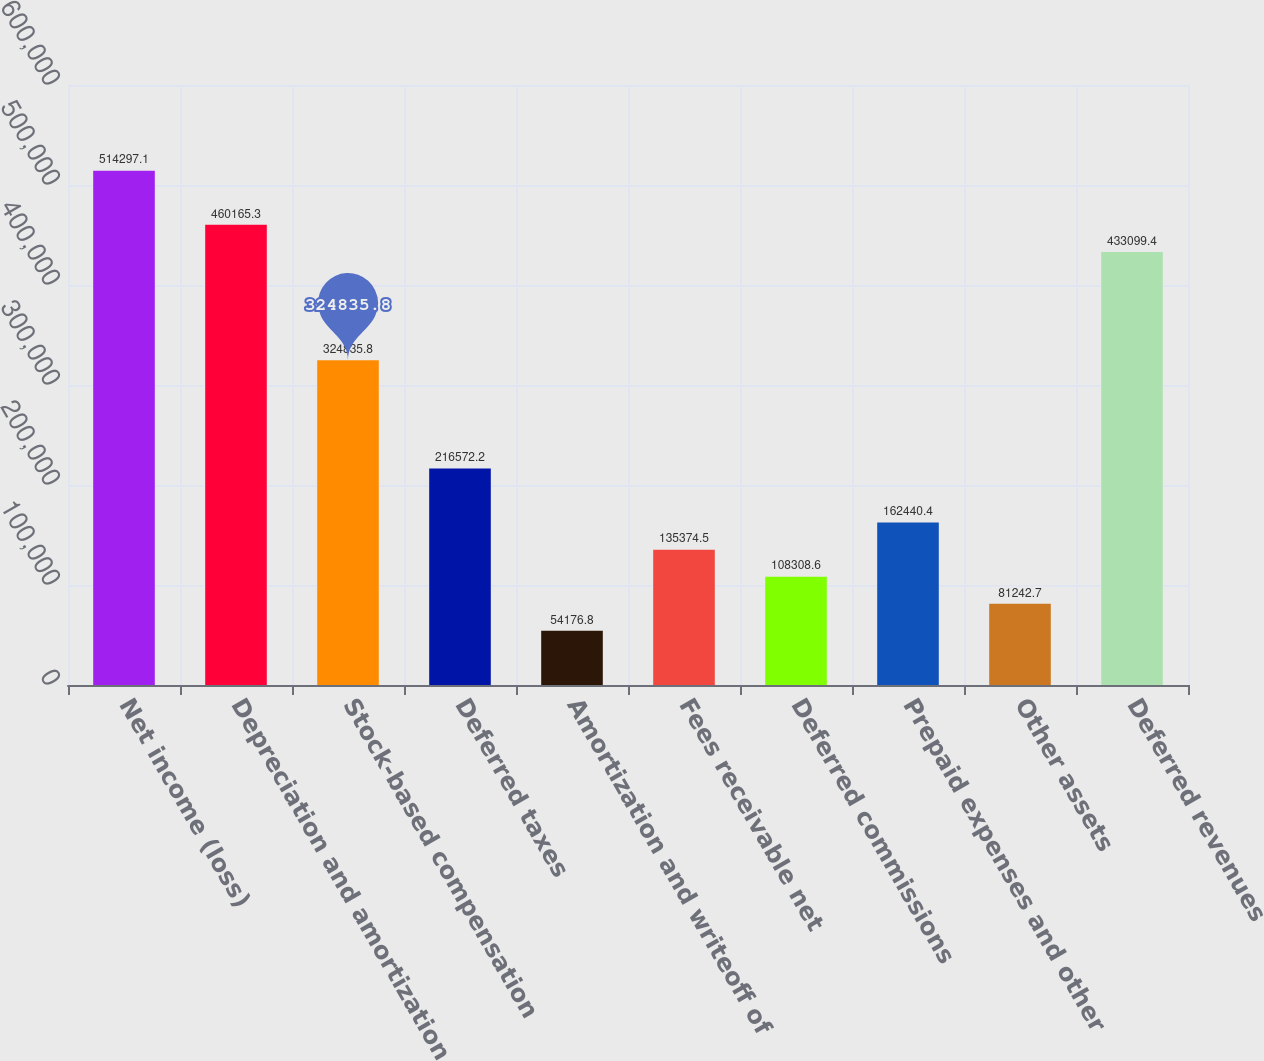<chart> <loc_0><loc_0><loc_500><loc_500><bar_chart><fcel>Net income (loss)<fcel>Depreciation and amortization<fcel>Stock-based compensation<fcel>Deferred taxes<fcel>Amortization and writeoff of<fcel>Fees receivable net<fcel>Deferred commissions<fcel>Prepaid expenses and other<fcel>Other assets<fcel>Deferred revenues<nl><fcel>514297<fcel>460165<fcel>324836<fcel>216572<fcel>54176.8<fcel>135374<fcel>108309<fcel>162440<fcel>81242.7<fcel>433099<nl></chart> 